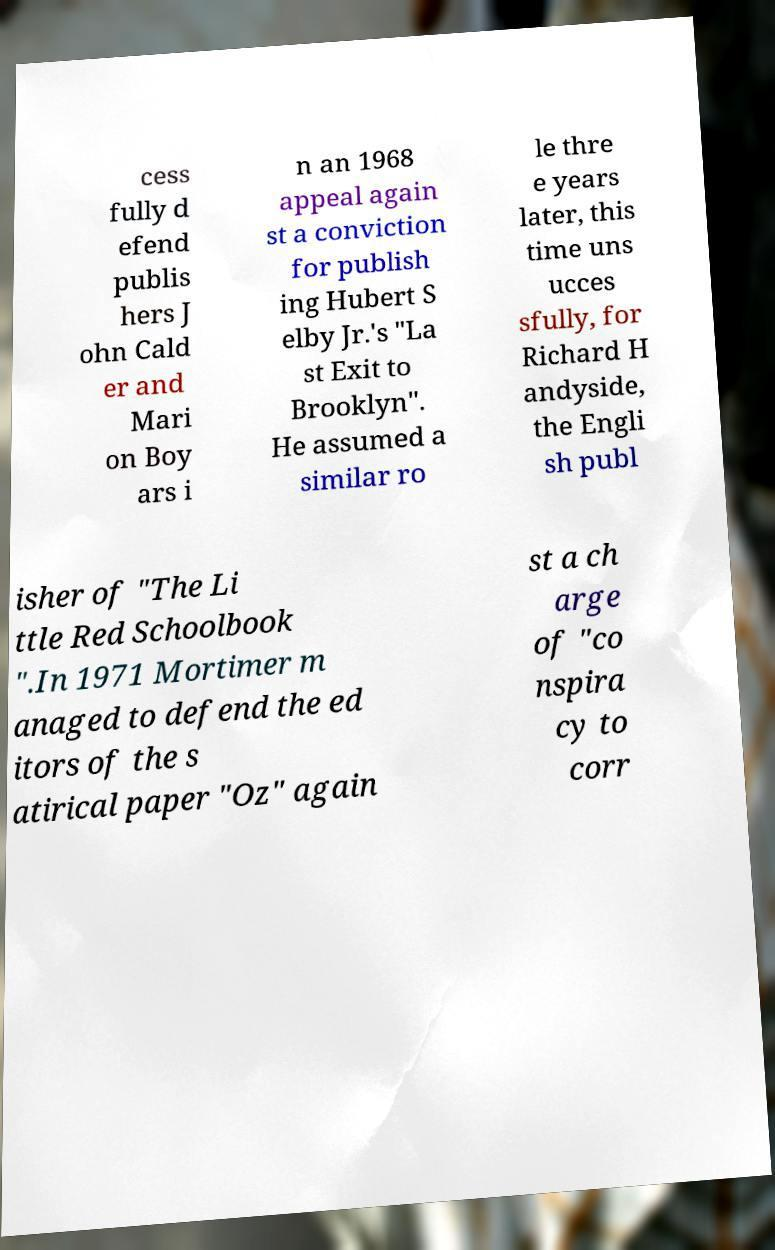For documentation purposes, I need the text within this image transcribed. Could you provide that? cess fully d efend publis hers J ohn Cald er and Mari on Boy ars i n an 1968 appeal again st a conviction for publish ing Hubert S elby Jr.'s "La st Exit to Brooklyn". He assumed a similar ro le thre e years later, this time uns ucces sfully, for Richard H andyside, the Engli sh publ isher of "The Li ttle Red Schoolbook ".In 1971 Mortimer m anaged to defend the ed itors of the s atirical paper "Oz" again st a ch arge of "co nspira cy to corr 